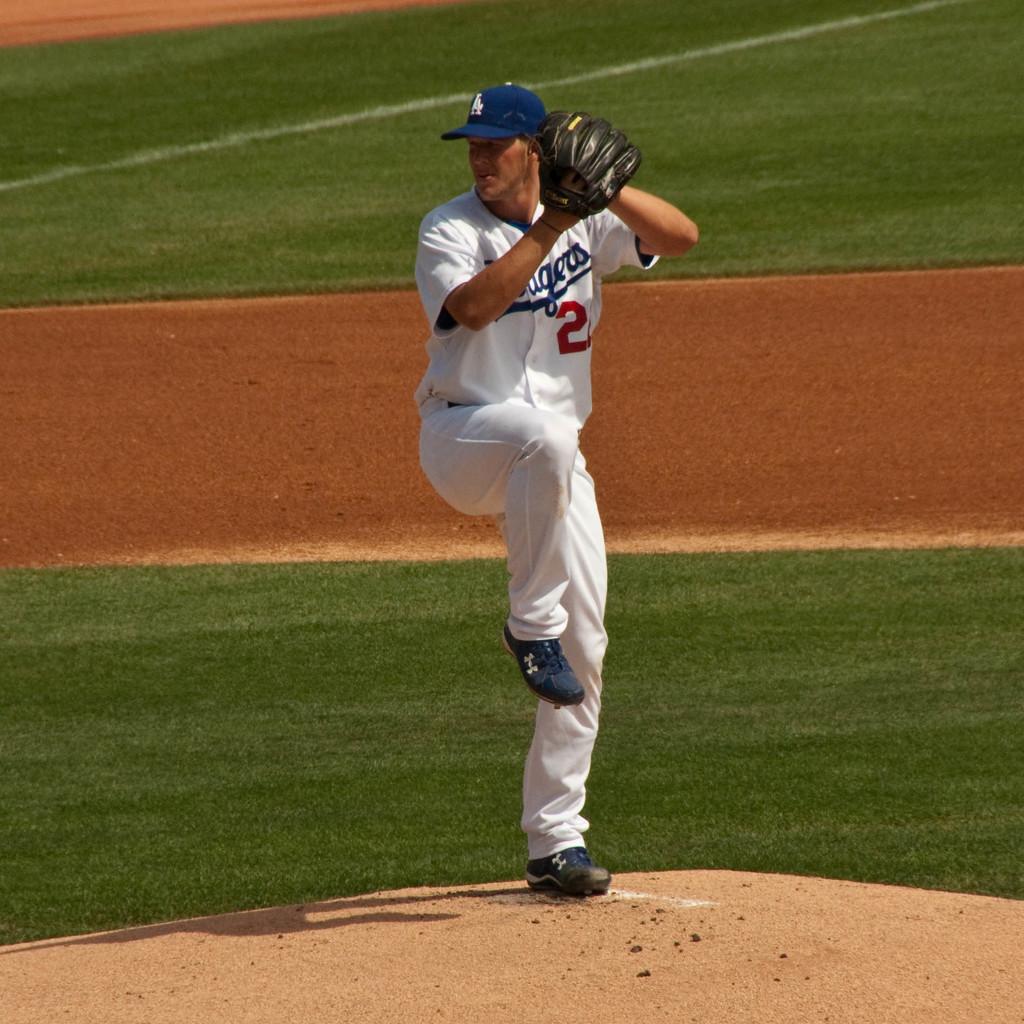What is his number?
Ensure brevity in your answer.  2. 